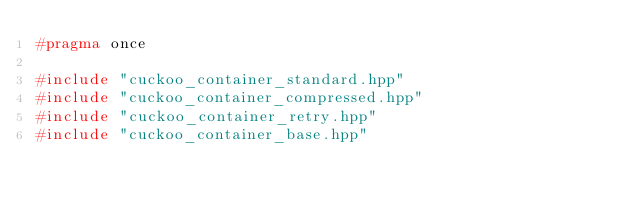<code> <loc_0><loc_0><loc_500><loc_500><_C++_>#pragma once

#include "cuckoo_container_standard.hpp"
#include "cuckoo_container_compressed.hpp"
#include "cuckoo_container_retry.hpp"
#include "cuckoo_container_base.hpp"

</code> 